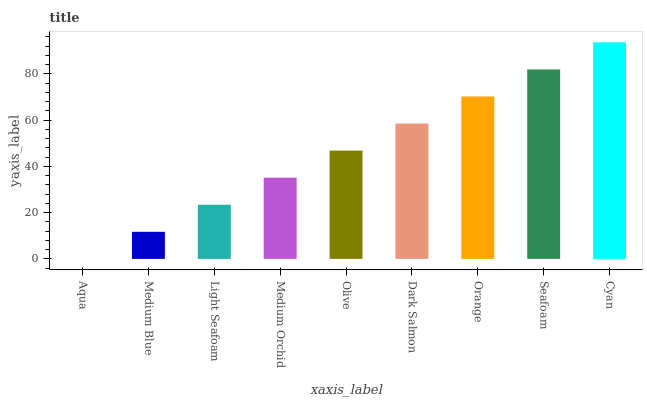Is Aqua the minimum?
Answer yes or no. Yes. Is Cyan the maximum?
Answer yes or no. Yes. Is Medium Blue the minimum?
Answer yes or no. No. Is Medium Blue the maximum?
Answer yes or no. No. Is Medium Blue greater than Aqua?
Answer yes or no. Yes. Is Aqua less than Medium Blue?
Answer yes or no. Yes. Is Aqua greater than Medium Blue?
Answer yes or no. No. Is Medium Blue less than Aqua?
Answer yes or no. No. Is Olive the high median?
Answer yes or no. Yes. Is Olive the low median?
Answer yes or no. Yes. Is Cyan the high median?
Answer yes or no. No. Is Seafoam the low median?
Answer yes or no. No. 